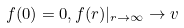Convert formula to latex. <formula><loc_0><loc_0><loc_500><loc_500>f ( 0 ) = 0 , f ( r ) | _ { r \rightarrow \infty } \rightarrow v</formula> 